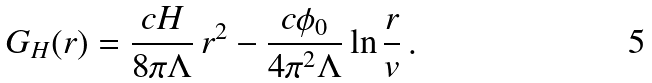Convert formula to latex. <formula><loc_0><loc_0><loc_500><loc_500>G _ { H } ( r ) = \frac { c H } { 8 \pi \Lambda } \, r ^ { 2 } - \frac { c \phi _ { 0 } } { 4 \pi ^ { 2 } \Lambda } \ln \frac { r } { v } \, .</formula> 